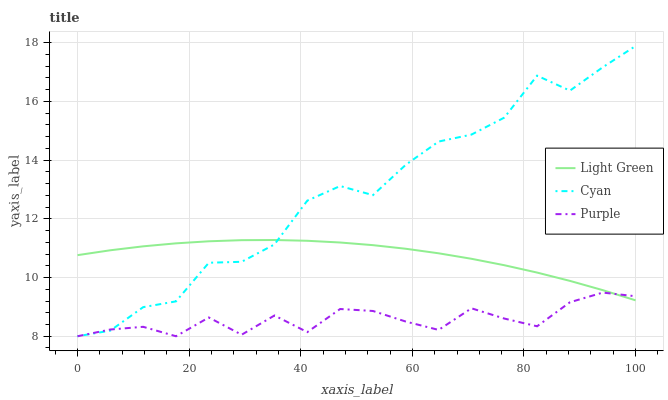Does Light Green have the minimum area under the curve?
Answer yes or no. No. Does Light Green have the maximum area under the curve?
Answer yes or no. No. Is Cyan the smoothest?
Answer yes or no. No. Is Light Green the roughest?
Answer yes or no. No. Does Light Green have the lowest value?
Answer yes or no. No. Does Light Green have the highest value?
Answer yes or no. No. 